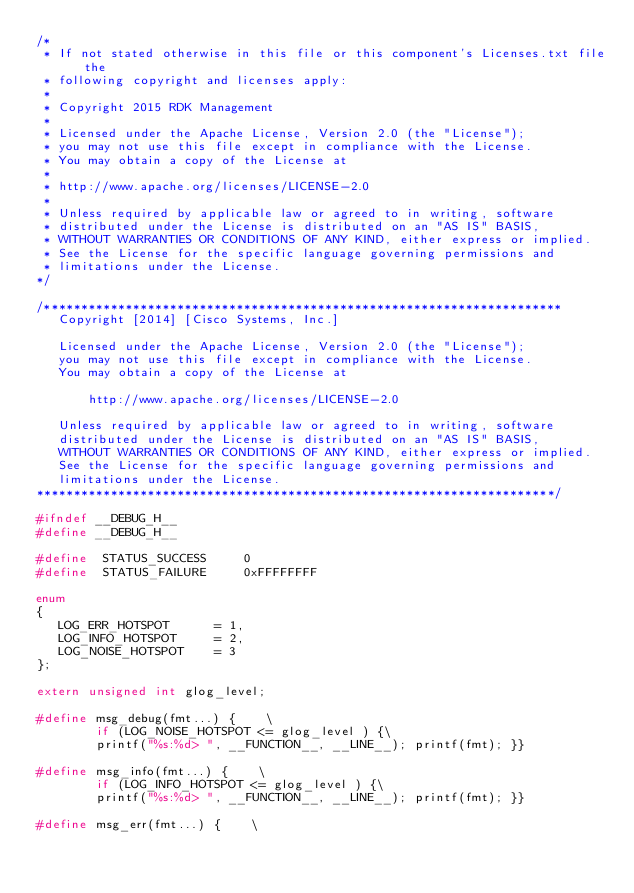Convert code to text. <code><loc_0><loc_0><loc_500><loc_500><_C_>/*
 * If not stated otherwise in this file or this component's Licenses.txt file the
 * following copyright and licenses apply:
 *
 * Copyright 2015 RDK Management
 *
 * Licensed under the Apache License, Version 2.0 (the "License");
 * you may not use this file except in compliance with the License.
 * You may obtain a copy of the License at
 *
 * http://www.apache.org/licenses/LICENSE-2.0
 *
 * Unless required by applicable law or agreed to in writing, software
 * distributed under the License is distributed on an "AS IS" BASIS,
 * WITHOUT WARRANTIES OR CONDITIONS OF ANY KIND, either express or implied.
 * See the License for the specific language governing permissions and
 * limitations under the License.
*/

/**********************************************************************
   Copyright [2014] [Cisco Systems, Inc.]
 
   Licensed under the Apache License, Version 2.0 (the "License");
   you may not use this file except in compliance with the License.
   You may obtain a copy of the License at
 
       http://www.apache.org/licenses/LICENSE-2.0
 
   Unless required by applicable law or agreed to in writing, software
   distributed under the License is distributed on an "AS IS" BASIS,
   WITHOUT WARRANTIES OR CONDITIONS OF ANY KIND, either express or implied.
   See the License for the specific language governing permissions and
   limitations under the License.
**********************************************************************/

#ifndef __DEBUG_H__   
#define __DEBUG_H__

#define  STATUS_SUCCESS     0
#define  STATUS_FAILURE     0xFFFFFFFF

enum
{
   LOG_ERR_HOTSPOT      = 1,
   LOG_INFO_HOTSPOT     = 2,
   LOG_NOISE_HOTSPOT    = 3
};

extern unsigned int glog_level;

#define msg_debug(fmt...) {    \
        if (LOG_NOISE_HOTSPOT <= glog_level ) {\
        printf("%s:%d> ", __FUNCTION__, __LINE__); printf(fmt); }}

#define msg_info(fmt...) {    \
        if (LOG_INFO_HOTSPOT <= glog_level ) {\
        printf("%s:%d> ", __FUNCTION__, __LINE__); printf(fmt); }}

#define msg_err(fmt...) {    \</code> 